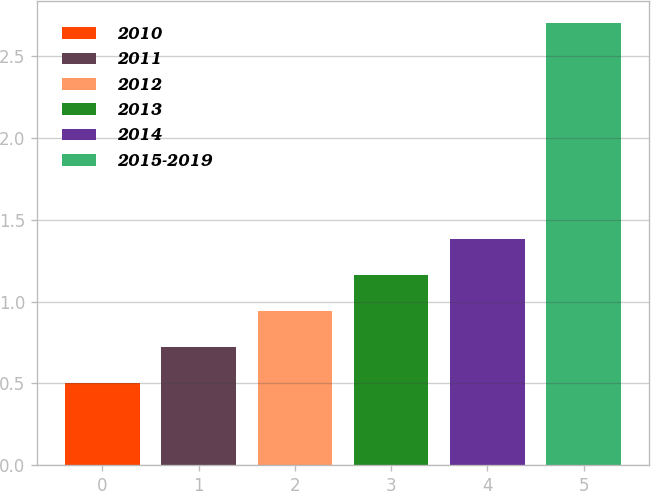<chart> <loc_0><loc_0><loc_500><loc_500><bar_chart><fcel>2010<fcel>2011<fcel>2012<fcel>2013<fcel>2014<fcel>2015-2019<nl><fcel>0.5<fcel>0.72<fcel>0.94<fcel>1.16<fcel>1.38<fcel>2.7<nl></chart> 